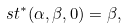<formula> <loc_0><loc_0><loc_500><loc_500>\ s t ^ { * } ( \alpha , \beta , 0 ) = \beta ,</formula> 